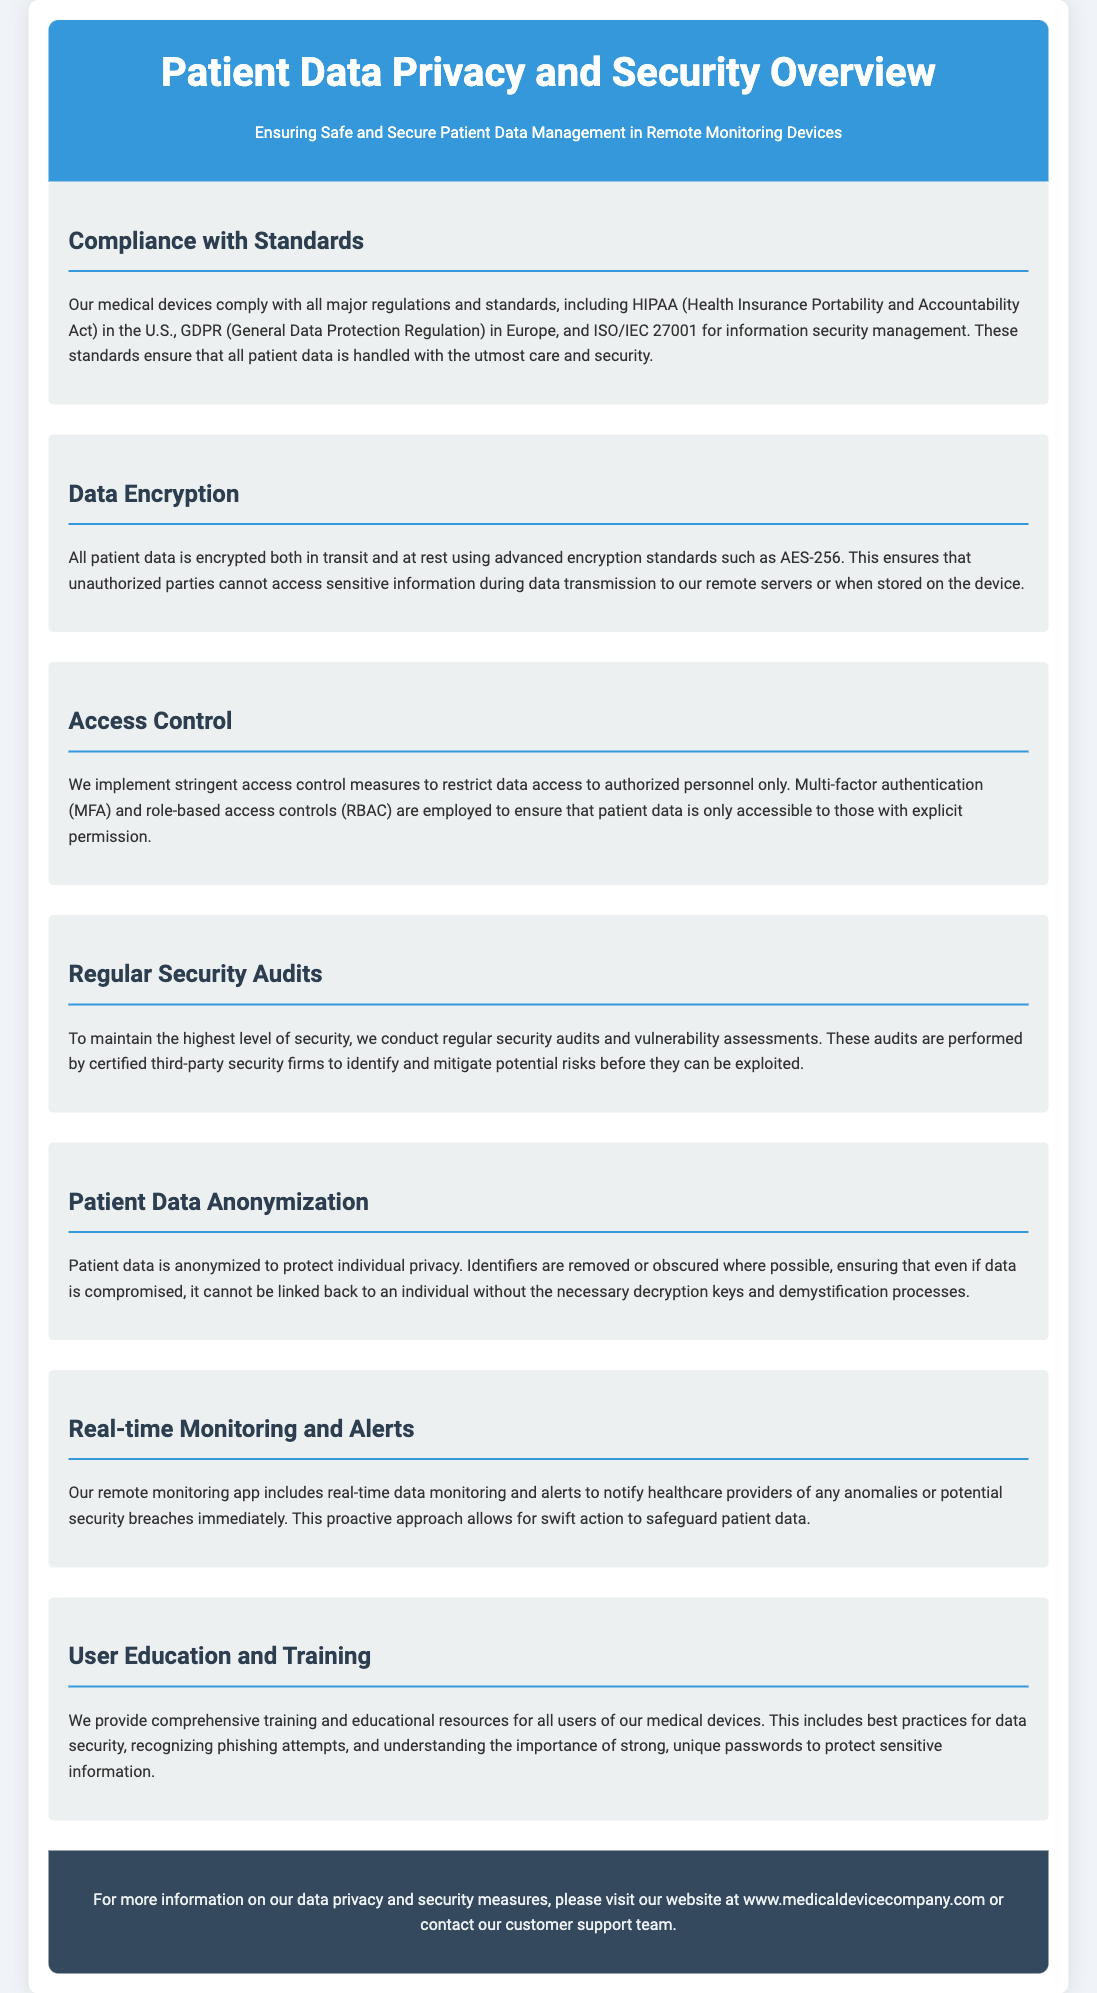What regulations does the document mention? The document mentions compliance with HIPAA, GDPR, and ISO/IEC 27001.
Answer: HIPAA, GDPR, ISO/IEC 27001 What type of data encryption is used? The document specifies that data is encrypted with advanced encryption standards such as AES-256.
Answer: AES-256 What control measures are employed for data access? The document states that multi-factor authentication (MFA) and role-based access controls (RBAC) are implemented.
Answer: MFA, RBAC How often are security audits conducted? The document implies that regular security audits are conducted.
Answer: Regular What is done to protect individual privacy? The document mentions that patient data is anonymized to protect privacy.
Answer: Anonymized What alerts does the remote monitoring app provide? The document states that real-time data monitoring and alerts notify of anomalies or potential security breaches.
Answer: Anomalies, security breaches What training is provided for users? The document outlines that comprehensive training and educational resources are provided regarding data security and phishing recognition.
Answer: Data security, phishing What is the objective of using strict access control measures? The document indicates that these measures restrict data access to authorized personnel only.
Answer: Authorized personnel only 